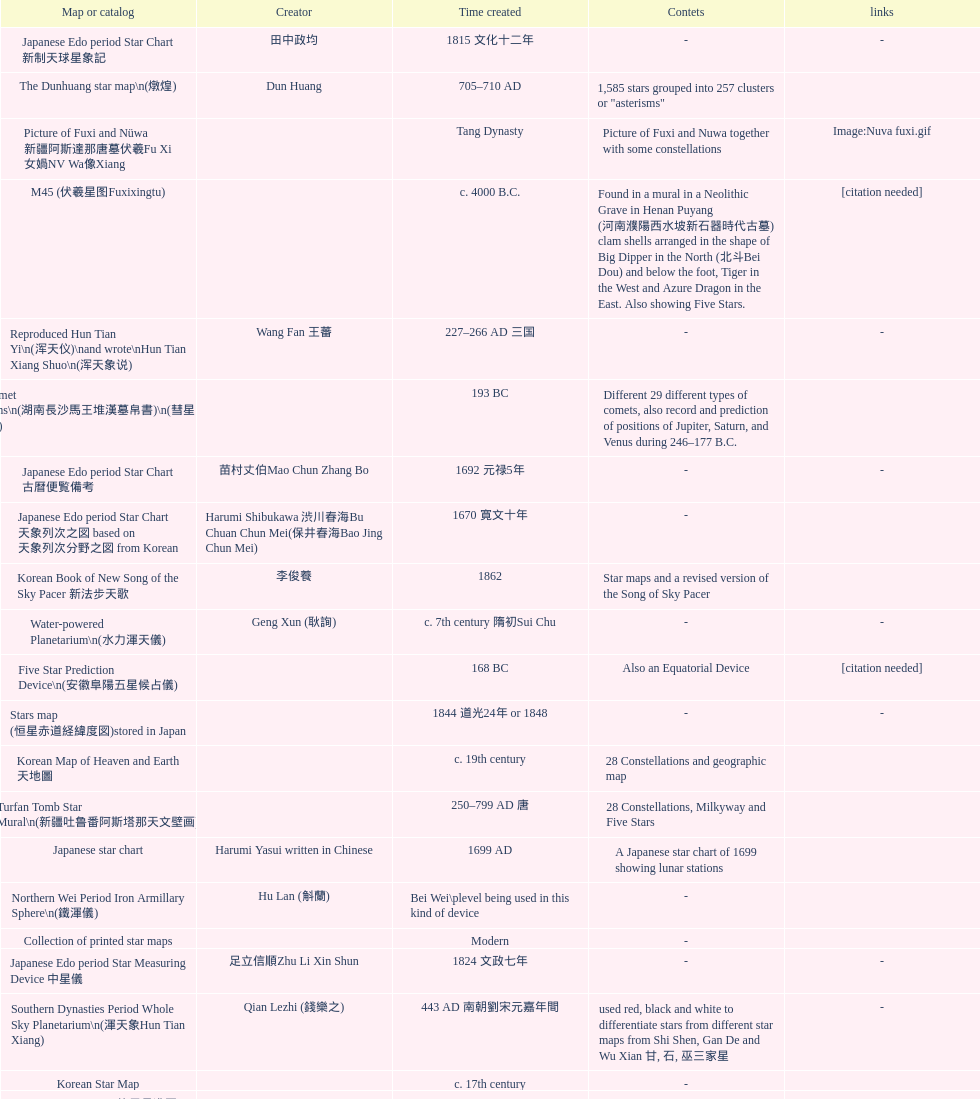Which was the first chinese star map known to have been created? M45 (伏羲星图Fuxixingtu). 